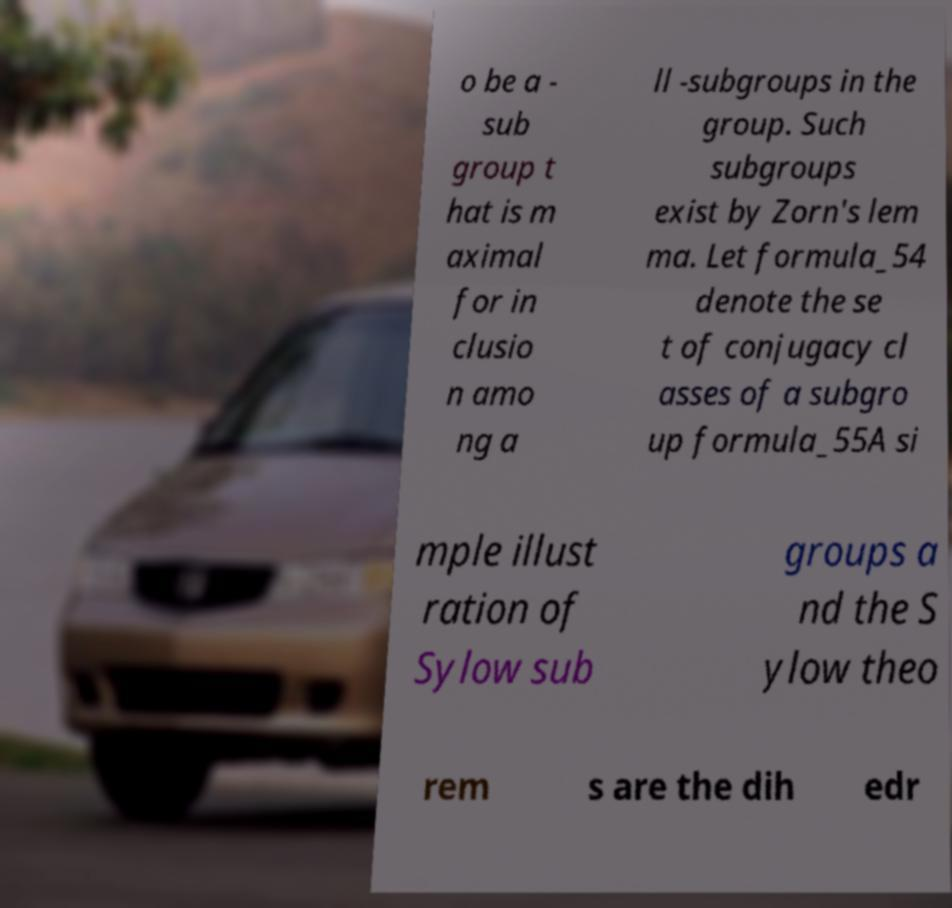Can you accurately transcribe the text from the provided image for me? o be a - sub group t hat is m aximal for in clusio n amo ng a ll -subgroups in the group. Such subgroups exist by Zorn's lem ma. Let formula_54 denote the se t of conjugacy cl asses of a subgro up formula_55A si mple illust ration of Sylow sub groups a nd the S ylow theo rem s are the dih edr 